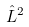Convert formula to latex. <formula><loc_0><loc_0><loc_500><loc_500>\hat { L } ^ { 2 }</formula> 